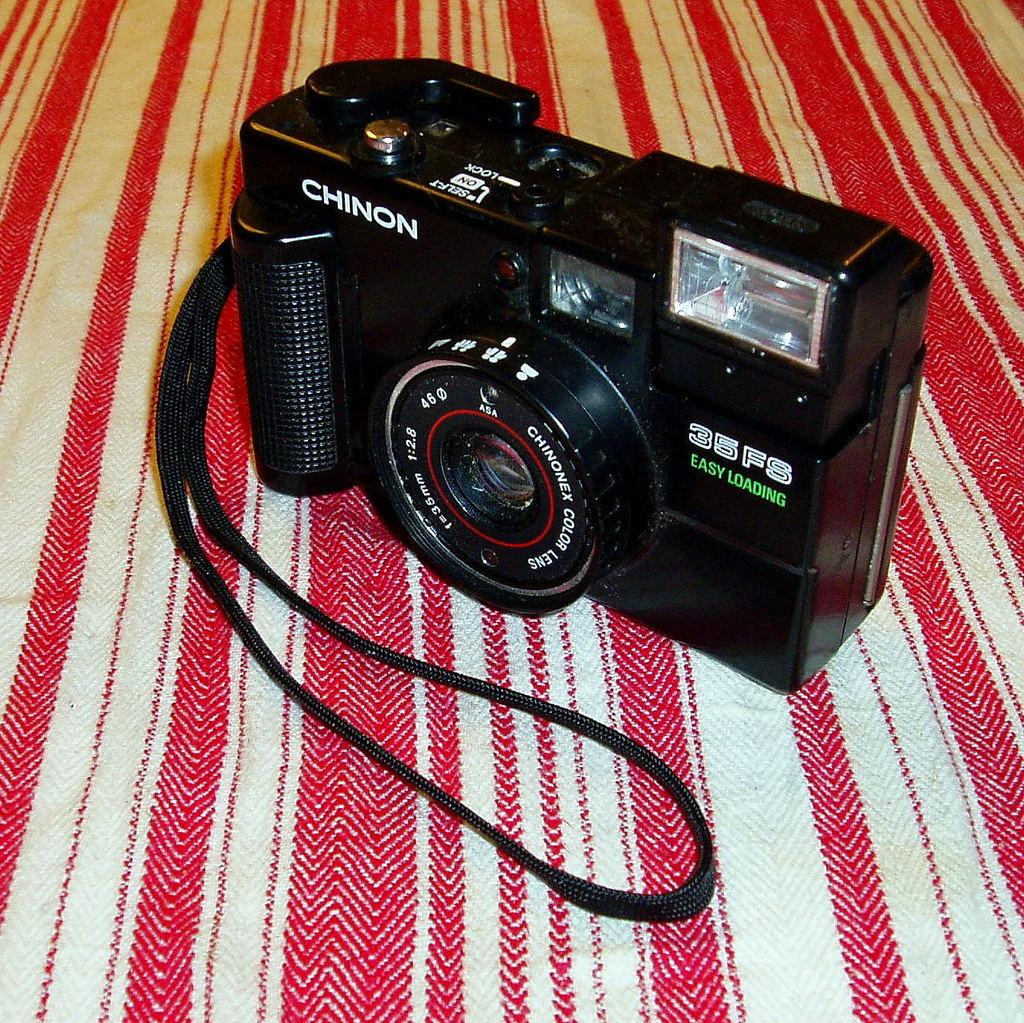What type of camera is visible in the image? There is a black digital camera in the image. Where is the camera located in the image? The camera is in the front of the image. What is present at the bottom of the image? There is cloth at the bottom of the image. What feature of the camera can be seen in the image? The flashlight of the camera is visible. How many letters are being delivered by the bell in the image? There is no bell present in the image, and therefore no letters are being delivered. 